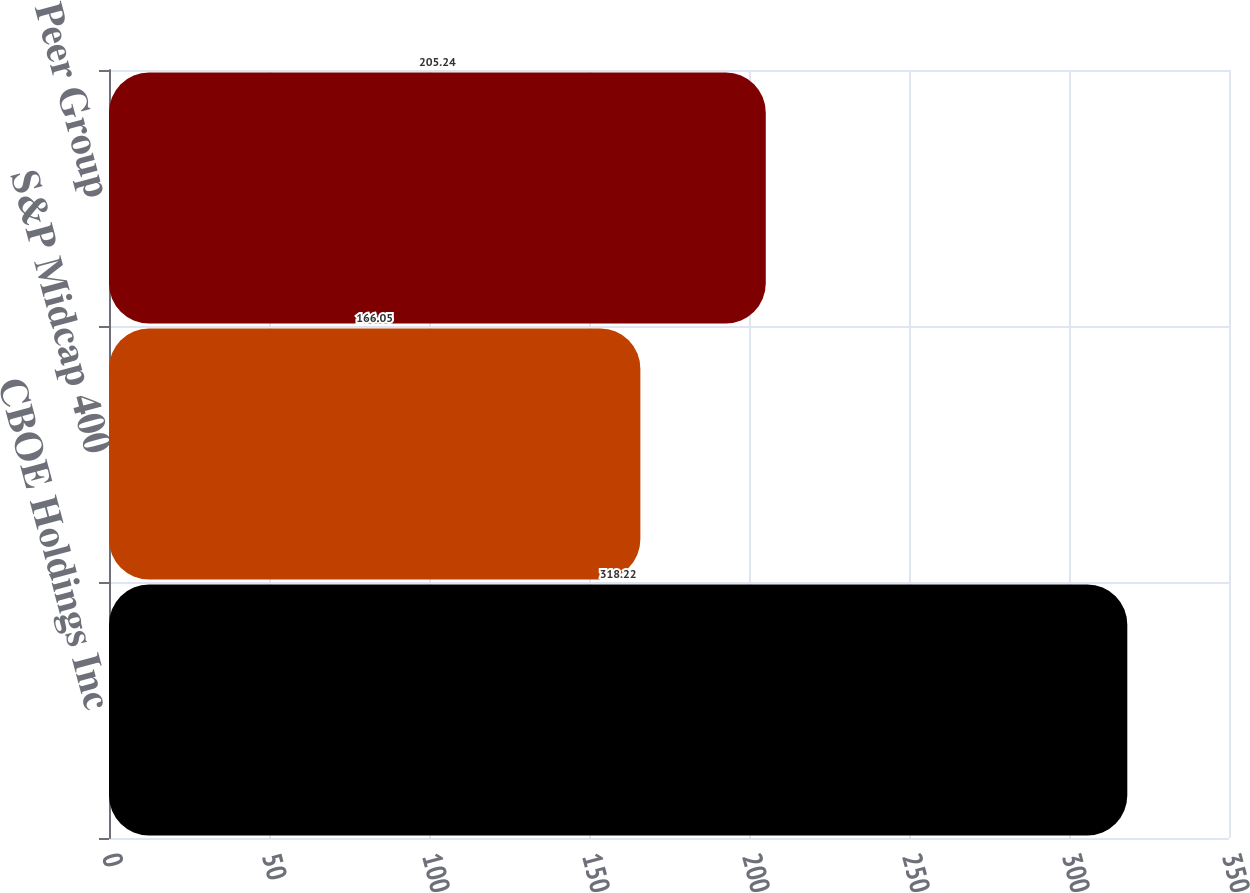Convert chart to OTSL. <chart><loc_0><loc_0><loc_500><loc_500><bar_chart><fcel>CBOE Holdings Inc<fcel>S&P Midcap 400<fcel>Peer Group<nl><fcel>318.22<fcel>166.05<fcel>205.24<nl></chart> 